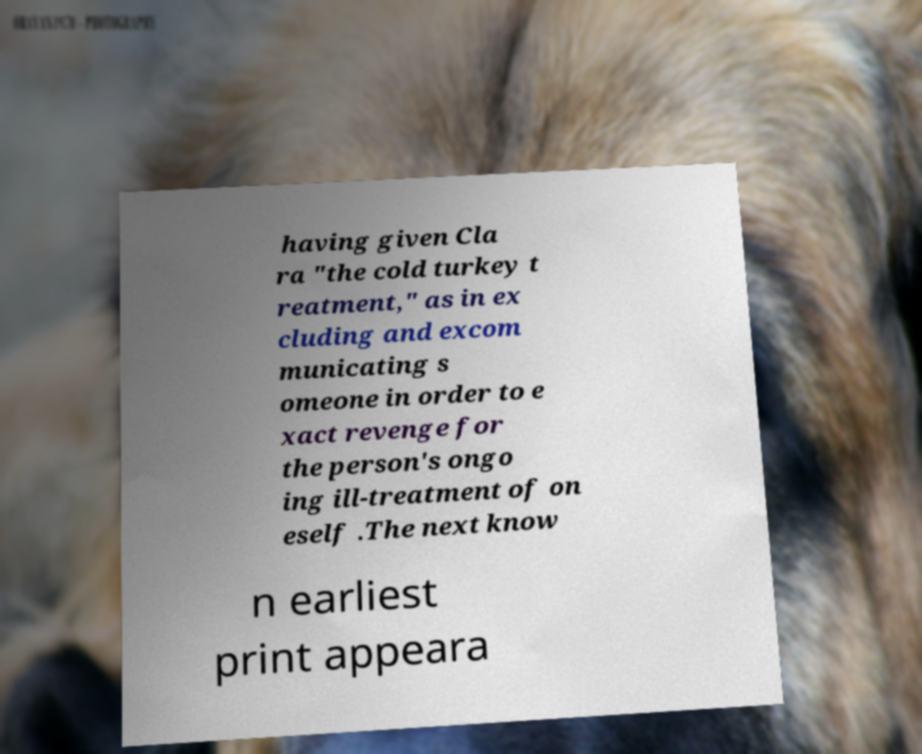Can you read and provide the text displayed in the image?This photo seems to have some interesting text. Can you extract and type it out for me? having given Cla ra "the cold turkey t reatment," as in ex cluding and excom municating s omeone in order to e xact revenge for the person's ongo ing ill-treatment of on eself .The next know n earliest print appeara 